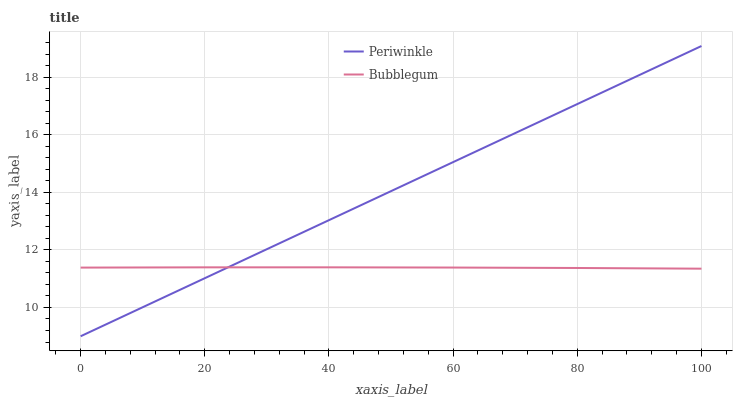Does Bubblegum have the minimum area under the curve?
Answer yes or no. Yes. Does Periwinkle have the maximum area under the curve?
Answer yes or no. Yes. Does Bubblegum have the maximum area under the curve?
Answer yes or no. No. Is Periwinkle the smoothest?
Answer yes or no. Yes. Is Bubblegum the roughest?
Answer yes or no. Yes. Is Bubblegum the smoothest?
Answer yes or no. No. Does Periwinkle have the lowest value?
Answer yes or no. Yes. Does Bubblegum have the lowest value?
Answer yes or no. No. Does Periwinkle have the highest value?
Answer yes or no. Yes. Does Bubblegum have the highest value?
Answer yes or no. No. Does Periwinkle intersect Bubblegum?
Answer yes or no. Yes. Is Periwinkle less than Bubblegum?
Answer yes or no. No. Is Periwinkle greater than Bubblegum?
Answer yes or no. No. 